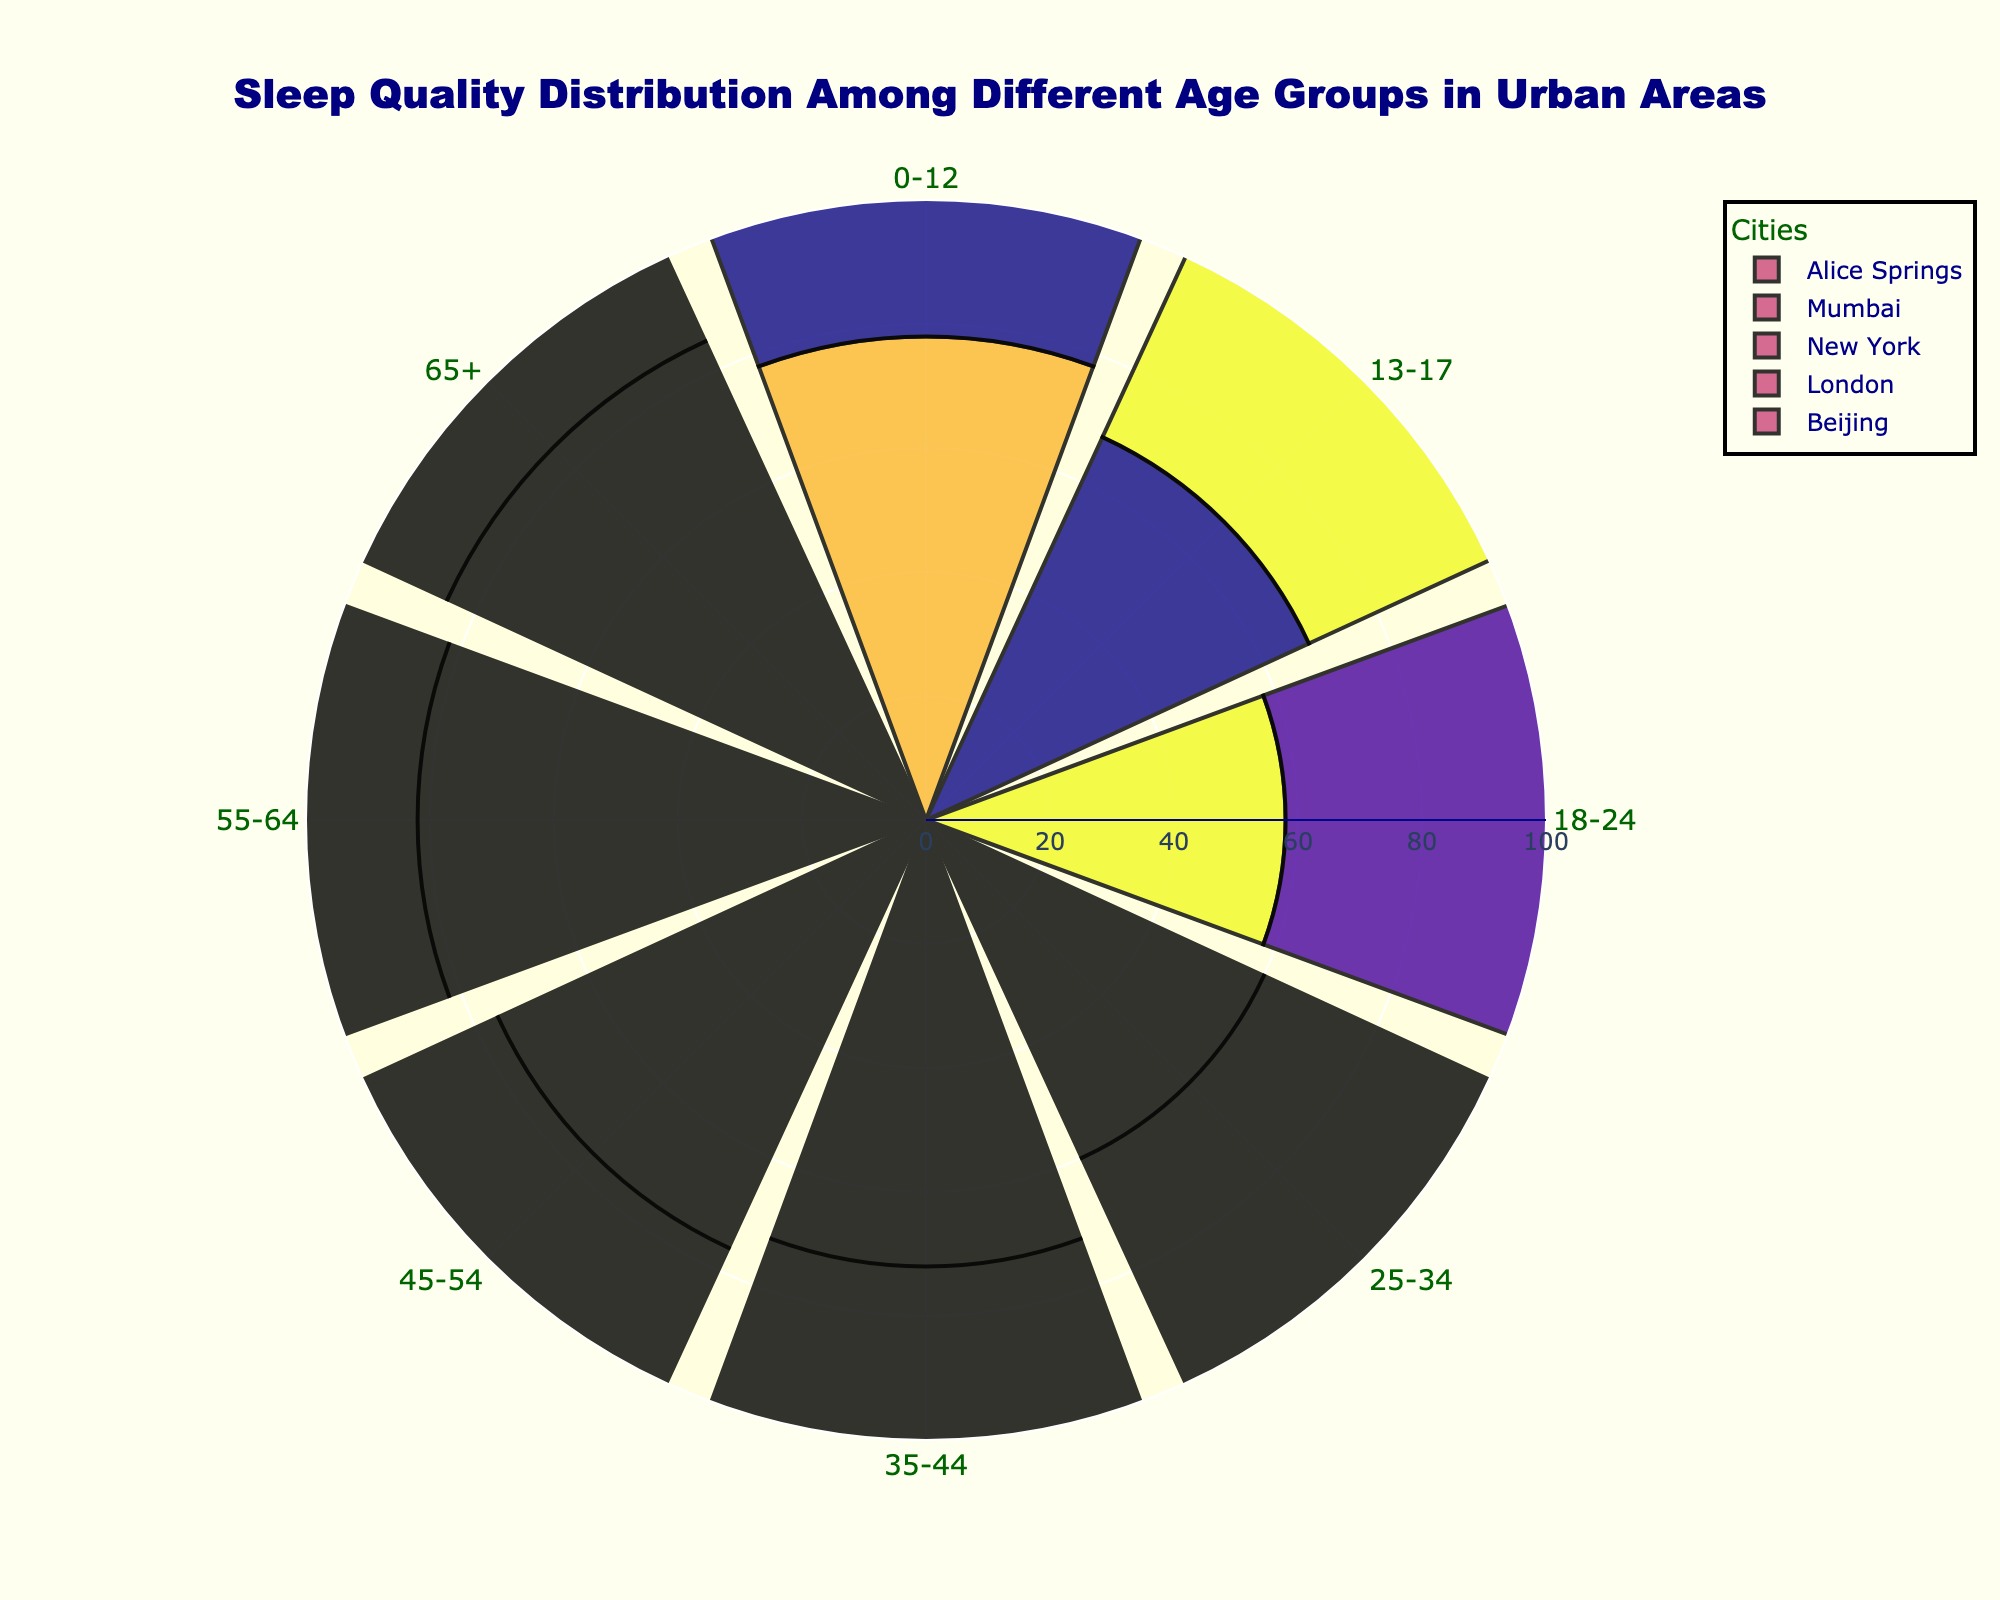What is the title of the figure? The title of the figure is typically displayed at the top. Here it states: "Sleep Quality Distribution Among Different Age Groups in Urban Areas".
Answer: Sleep Quality Distribution Among Different Age Groups in Urban Areas Which age group in New York has the highest average sleep quality? By looking at the radial bars for New York, the longest bar corresponds to the age group 65+, indicating the highest average sleep quality.
Answer: 65+ How does the average sleep quality for age group 18-24 in London compare to Mumbai? Comparing the lengths of the bars for the age group 18-24 between London and Mumbai shows that London's bar is slightly longer than Mumbai's, indicating a higher average sleep quality in London.
Answer: London has higher What's the general trend of sleep quality as age increases for Beijing? Observing the radial bars from the youngest to the oldest age groups for Beijing shows an increasing pattern in length, indicating an upward trend in sleep quality as age increases.
Answer: Increasing What is the average sleep quality difference between the age groups 0-12 and 45-54 in Alice Springs? The average sleep quality for age group 0-12 in Alice Springs is 78, and for the age group 45-54, it is 76. The difference is 78 - 76 = 2.
Answer: 2 Which city has the lowest sleep quality for the 13-17 age group? By examining the radial bars for the 13-17 age group, the shortest bar is for Mumbai, indicating the lowest average sleep quality.
Answer: Mumbai Compare the sleep quality of age group 55-64 between Beijing and Alice Springs, and determine which city has better sleep quality. By comparing the lengths of bars for the age group 55-64 in Beijing and Alice Springs, it can be observed that Alice Springs has a slightly longer bar. Therefore, Alice Springs has better sleep quality.
Answer: Alice Springs What age group in London has the least variation in sleep quality compared to other cities? By comparing the bars of similar lengths across different cities, the age group 25-34 in London appears to have relatively similar lengths compared to other cities, indicating the least variation.
Answer: 25-34 Calculate the mean average sleep quality for all age groups in New York. Sums of average sleep quality for New York's age groups: 80 + 70 + 62 + 64 + 74 + 78 + 85 + 88 = 601. There are 8 age groups, so the mean is 601 / 8 = 75.125.
Answer: 75.125 Which age group shows the highest sleep quality improvement from age group 18-24 to 25-34 in London? The differences in sleep quality between age groups 18-24 and 25-34 can be calculated: 61 (25-34) - 61 (18-24) = 4 for London. Comparatively, this is the highest improvement among age groups in London.
Answer: 25-34 